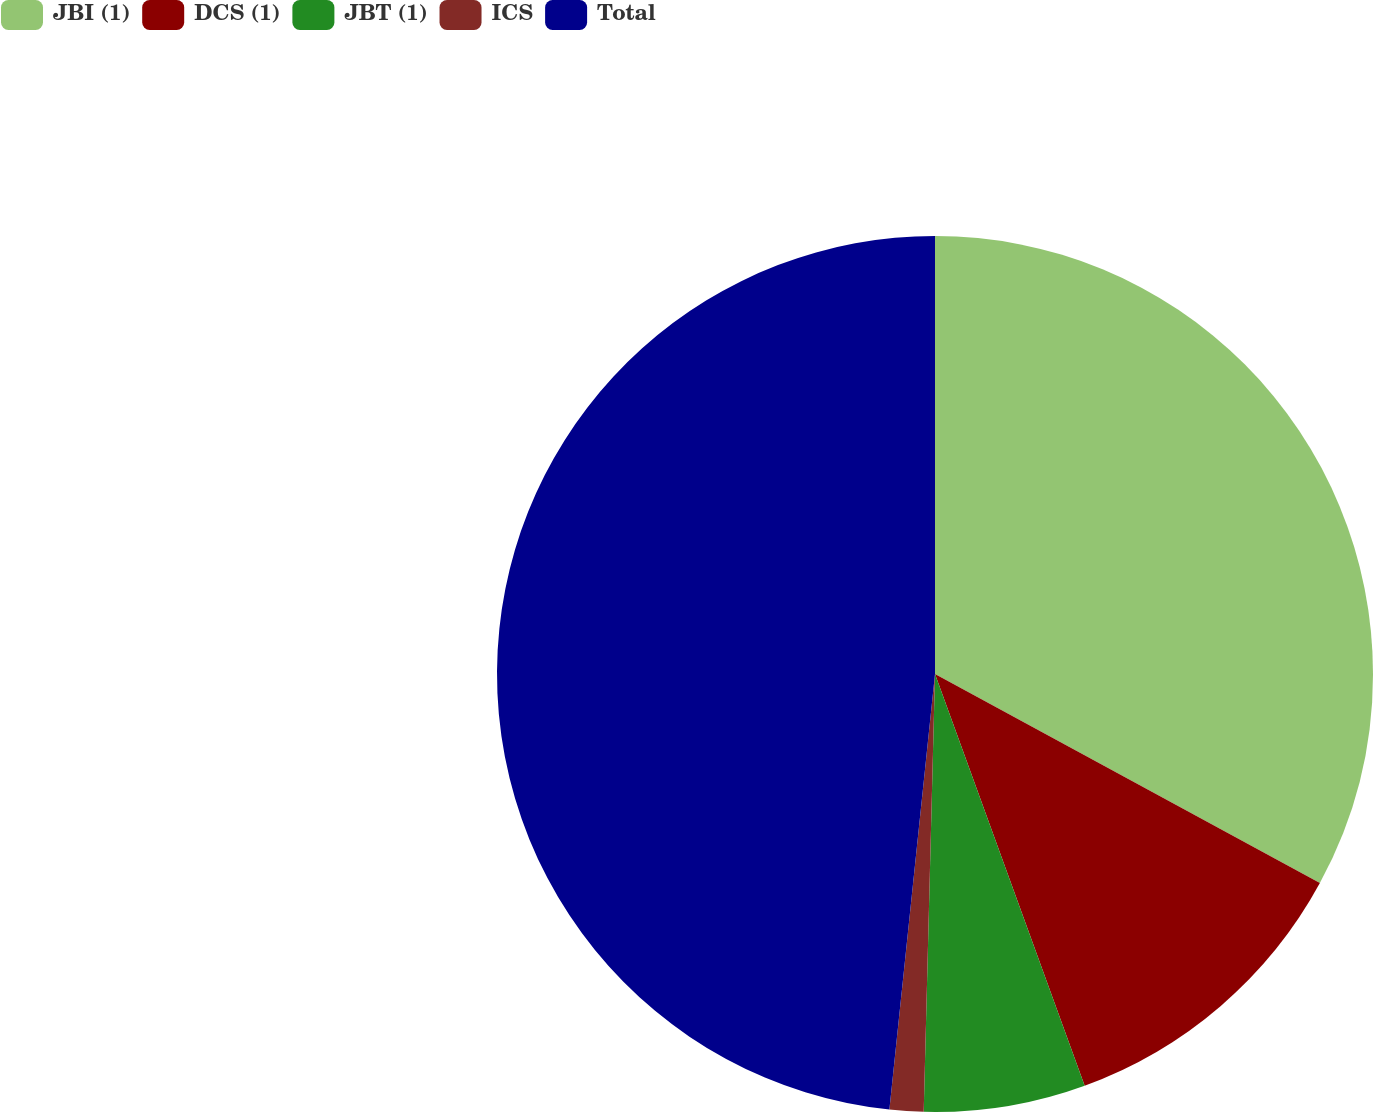Convert chart. <chart><loc_0><loc_0><loc_500><loc_500><pie_chart><fcel>JBI (1)<fcel>DCS (1)<fcel>JBT (1)<fcel>ICS<fcel>Total<nl><fcel>32.92%<fcel>11.53%<fcel>5.96%<fcel>1.25%<fcel>48.34%<nl></chart> 